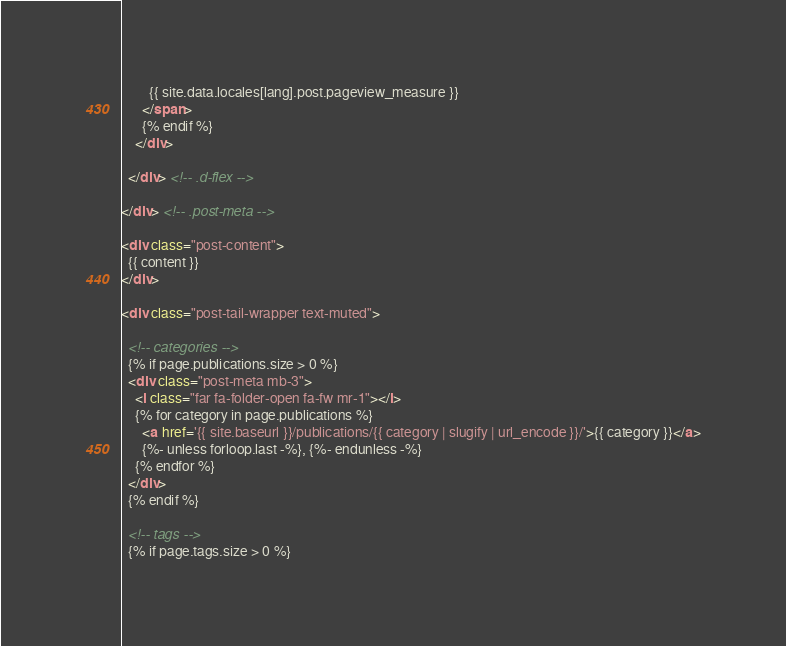Convert code to text. <code><loc_0><loc_0><loc_500><loc_500><_HTML_>        {{ site.data.locales[lang].post.pageview_measure }}
      </span>
      {% endif %}
    </div>

  </div> <!-- .d-flex -->

</div> <!-- .post-meta -->

<div class="post-content">
  {{ content }}
</div>

<div class="post-tail-wrapper text-muted">

  <!-- categories -->
  {% if page.publications.size > 0 %}
  <div class="post-meta mb-3">
    <i class="far fa-folder-open fa-fw mr-1"></i>
    {% for category in page.publications %}
      <a href='{{ site.baseurl }}/publications/{{ category | slugify | url_encode }}/'>{{ category }}</a>
      {%- unless forloop.last -%}, {%- endunless -%}
    {% endfor %}
  </div>
  {% endif %}

  <!-- tags -->
  {% if page.tags.size > 0 %}</code> 